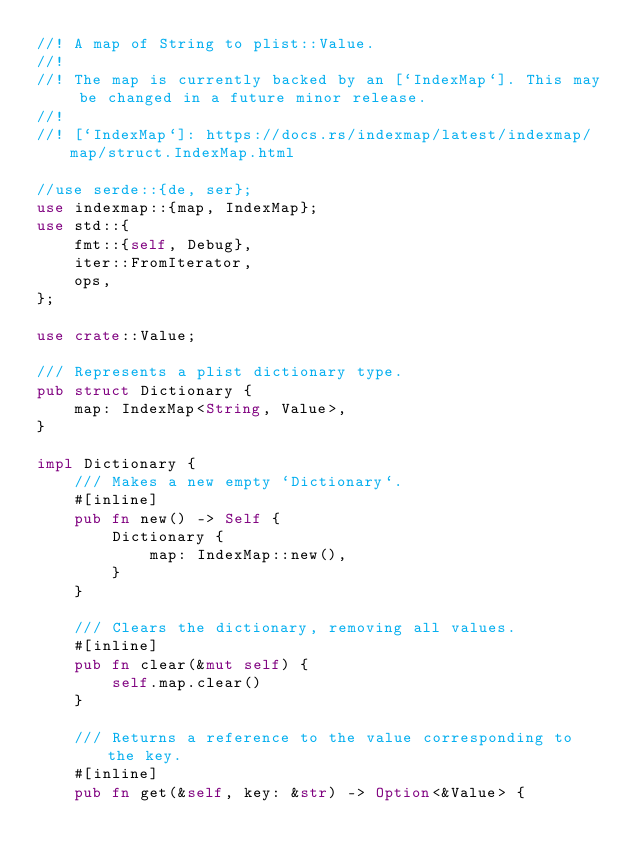Convert code to text. <code><loc_0><loc_0><loc_500><loc_500><_Rust_>//! A map of String to plist::Value.
//!
//! The map is currently backed by an [`IndexMap`]. This may be changed in a future minor release.
//!
//! [`IndexMap`]: https://docs.rs/indexmap/latest/indexmap/map/struct.IndexMap.html

//use serde::{de, ser};
use indexmap::{map, IndexMap};
use std::{
    fmt::{self, Debug},
    iter::FromIterator,
    ops,
};

use crate::Value;

/// Represents a plist dictionary type.
pub struct Dictionary {
    map: IndexMap<String, Value>,
}

impl Dictionary {
    /// Makes a new empty `Dictionary`.
    #[inline]
    pub fn new() -> Self {
        Dictionary {
            map: IndexMap::new(),
        }
    }

    /// Clears the dictionary, removing all values.
    #[inline]
    pub fn clear(&mut self) {
        self.map.clear()
    }

    /// Returns a reference to the value corresponding to the key.
    #[inline]
    pub fn get(&self, key: &str) -> Option<&Value> {</code> 